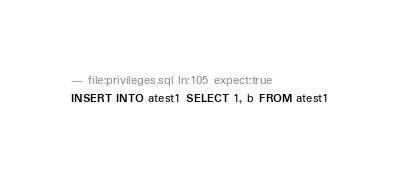Convert code to text. <code><loc_0><loc_0><loc_500><loc_500><_SQL_>-- file:privileges.sql ln:105 expect:true
INSERT INTO atest1 SELECT 1, b FROM atest1
</code> 